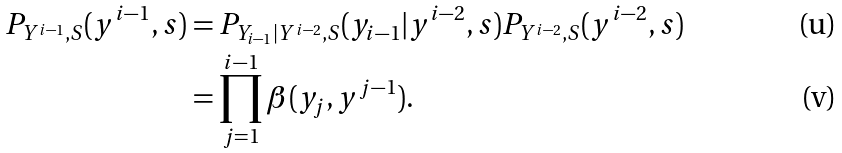<formula> <loc_0><loc_0><loc_500><loc_500>P _ { Y ^ { i - 1 } , { S } } ( y ^ { i - 1 } , { s } ) & = P _ { Y _ { i - 1 } | Y ^ { i - 2 } , { S } } ( y _ { i - 1 } | y ^ { i - 2 } , { s } ) P _ { Y ^ { i - 2 } , { S } } ( y ^ { i - 2 } , { s } ) \\ & = \prod _ { j = 1 } ^ { i - 1 } \beta ( y _ { j } , y ^ { j - 1 } ) .</formula> 